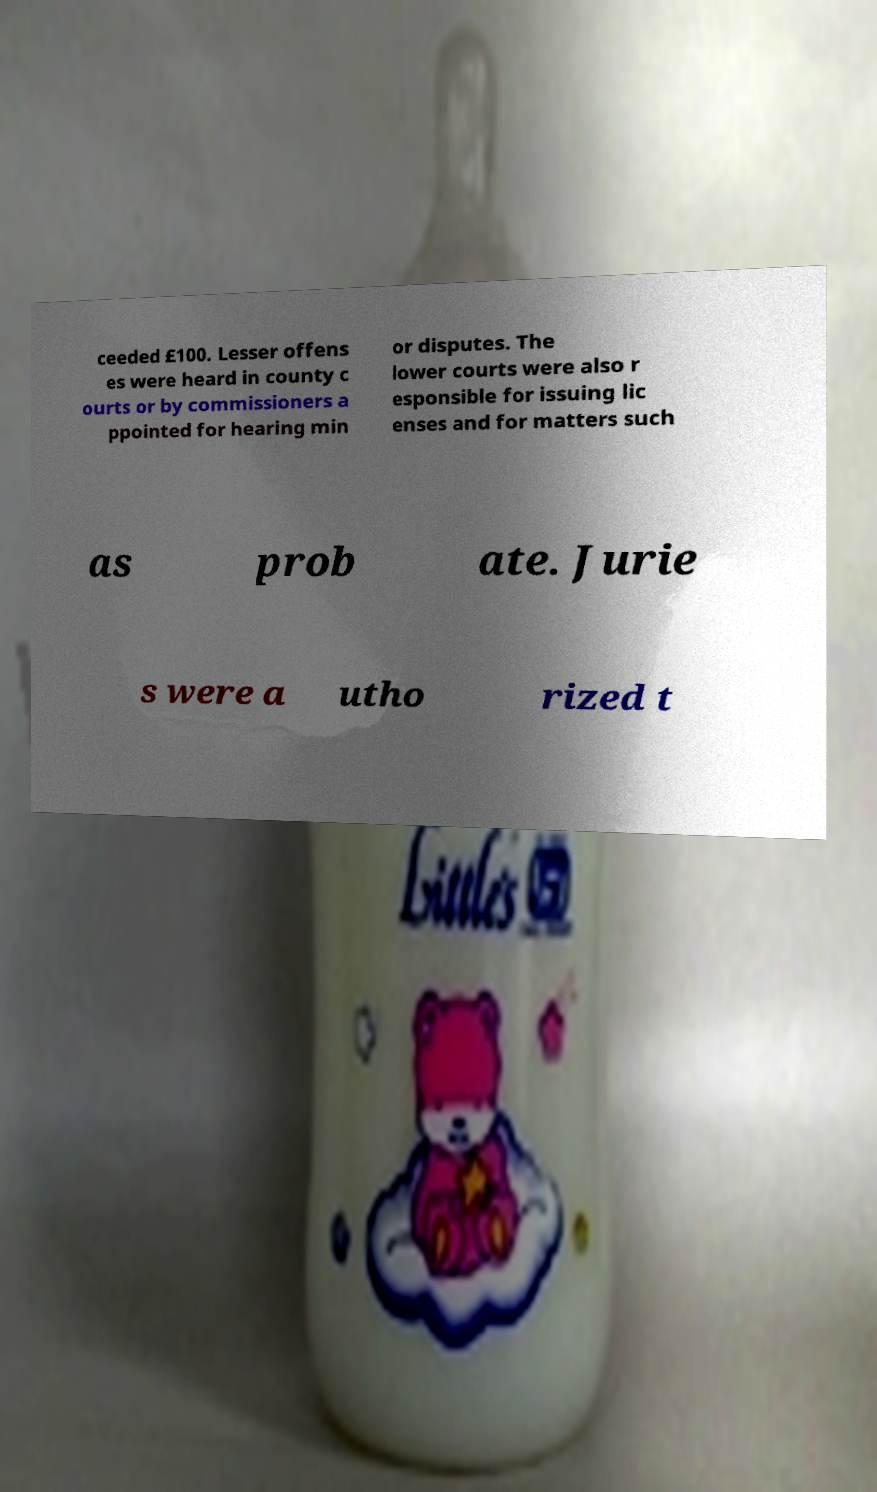I need the written content from this picture converted into text. Can you do that? ceeded £100. Lesser offens es were heard in county c ourts or by commissioners a ppointed for hearing min or disputes. The lower courts were also r esponsible for issuing lic enses and for matters such as prob ate. Jurie s were a utho rized t 